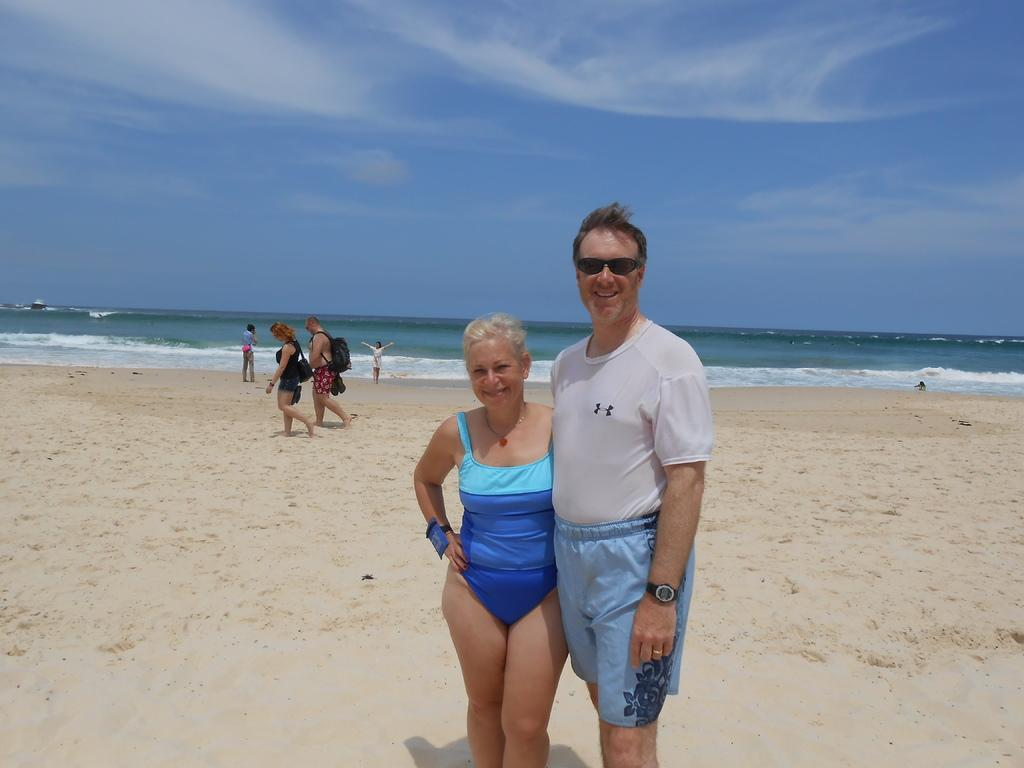Where was the image taken? The image was taken at a beach. What can be seen in the foreground of the picture? There are people and sand in the foreground of the picture. What is visible in the middle of the picture? There are people and a water body in the middle of the picture. What is visible at the top of the image? The sky is visible at the top of the image. How many boxes of sand can be seen in the image? There are no boxes of sand present in the image; it features sand in the foreground. What type of voyage is depicted in the image? There is no voyage depicted in the image; it shows people at a beach with a water body and sand. 